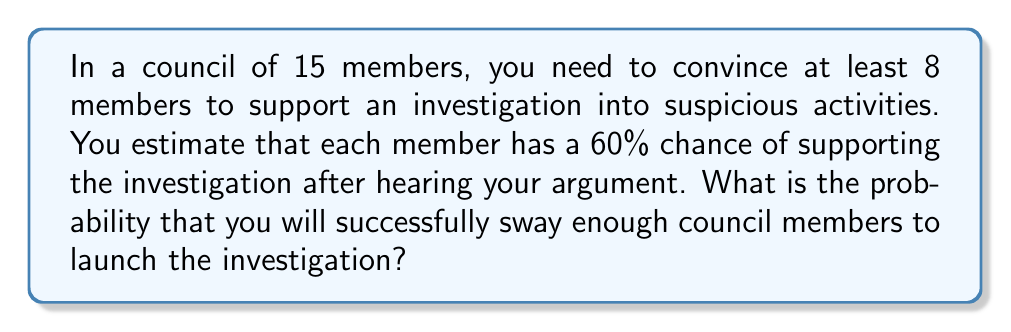What is the answer to this math problem? To solve this problem, we need to use the binomial probability distribution:

1) We have $n = 15$ trials (council members)
2) The probability of success (supporting the investigation) is $p = 0.60$
3) We need at least $k = 8$ successes

The probability of exactly $x$ successes in $n$ trials is given by:

$$P(X = x) = \binom{n}{x} p^x (1-p)^{n-x}$$

We need to sum this probability for $x = 8$ to $15$:

$$P(X \geq 8) = \sum_{x=8}^{15} \binom{15}{x} (0.60)^x (0.40)^{15-x}$$

Let's calculate each term:

$$\begin{align*}
P(X = 8) &= \binom{15}{8} (0.60)^8 (0.40)^7 \approx 0.1308 \\
P(X = 9) &= \binom{15}{9} (0.60)^9 (0.40)^6 \approx 0.1711 \\
P(X = 10) &= \binom{15}{10} (0.60)^{10} (0.40)^5 \approx 0.1711 \\
P(X = 11) &= \binom{15}{11} (0.60)^{11} (0.40)^4 \approx 0.1317 \\
P(X = 12) &= \binom{15}{12} (0.60)^{12} (0.40)^3 \approx 0.0769 \\
P(X = 13) &= \binom{15}{13} (0.60)^{13} (0.40)^2 \approx 0.0330 \\
P(X = 14) &= \binom{15}{14} (0.60)^{14} (0.40)^1 \approx 0.0099 \\
P(X = 15) &= \binom{15}{15} (0.60)^{15} (0.40)^0 \approx 0.0013
\end{align*}$$

Summing these probabilities:

$$P(X \geq 8) \approx 0.1308 + 0.1711 + 0.1711 + 0.1317 + 0.0769 + 0.0330 + 0.0099 + 0.0013 \approx 0.7258$$
Answer: $0.7258$ or $72.58\%$ 